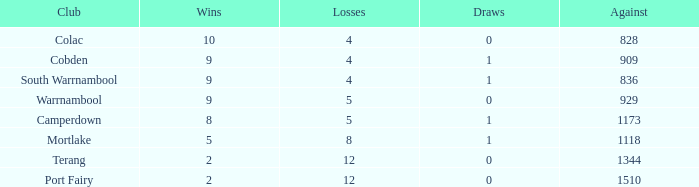What is the aggregate of wins for port fairy with less than 1510 against? None. 